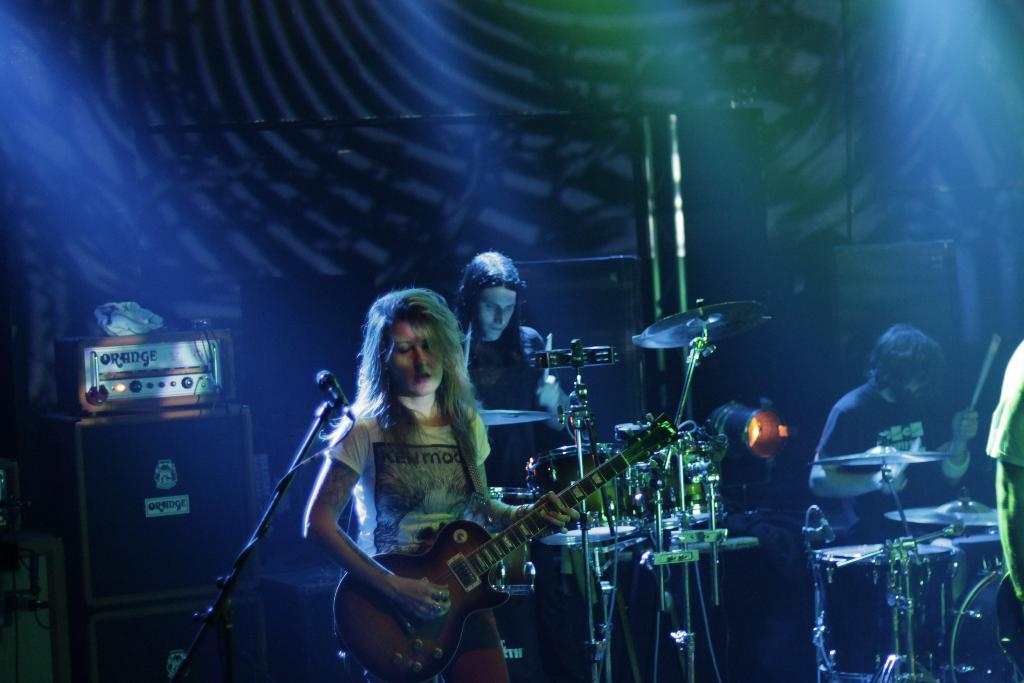How many people are in the image? There are three people in the image. What are the people doing in the image? The people are playing musical instruments. What equipment is visible in the image that might be used for amplifying sound? There are microphones (mics) visible in the image. Can you describe any other objects present in the image? There are other unspecified objects present in the image. What type of skirt is the person wearing in the image? There is no information about a skirt or any clothing in the image; the focus is on the people playing musical instruments and the presence of microphones. 